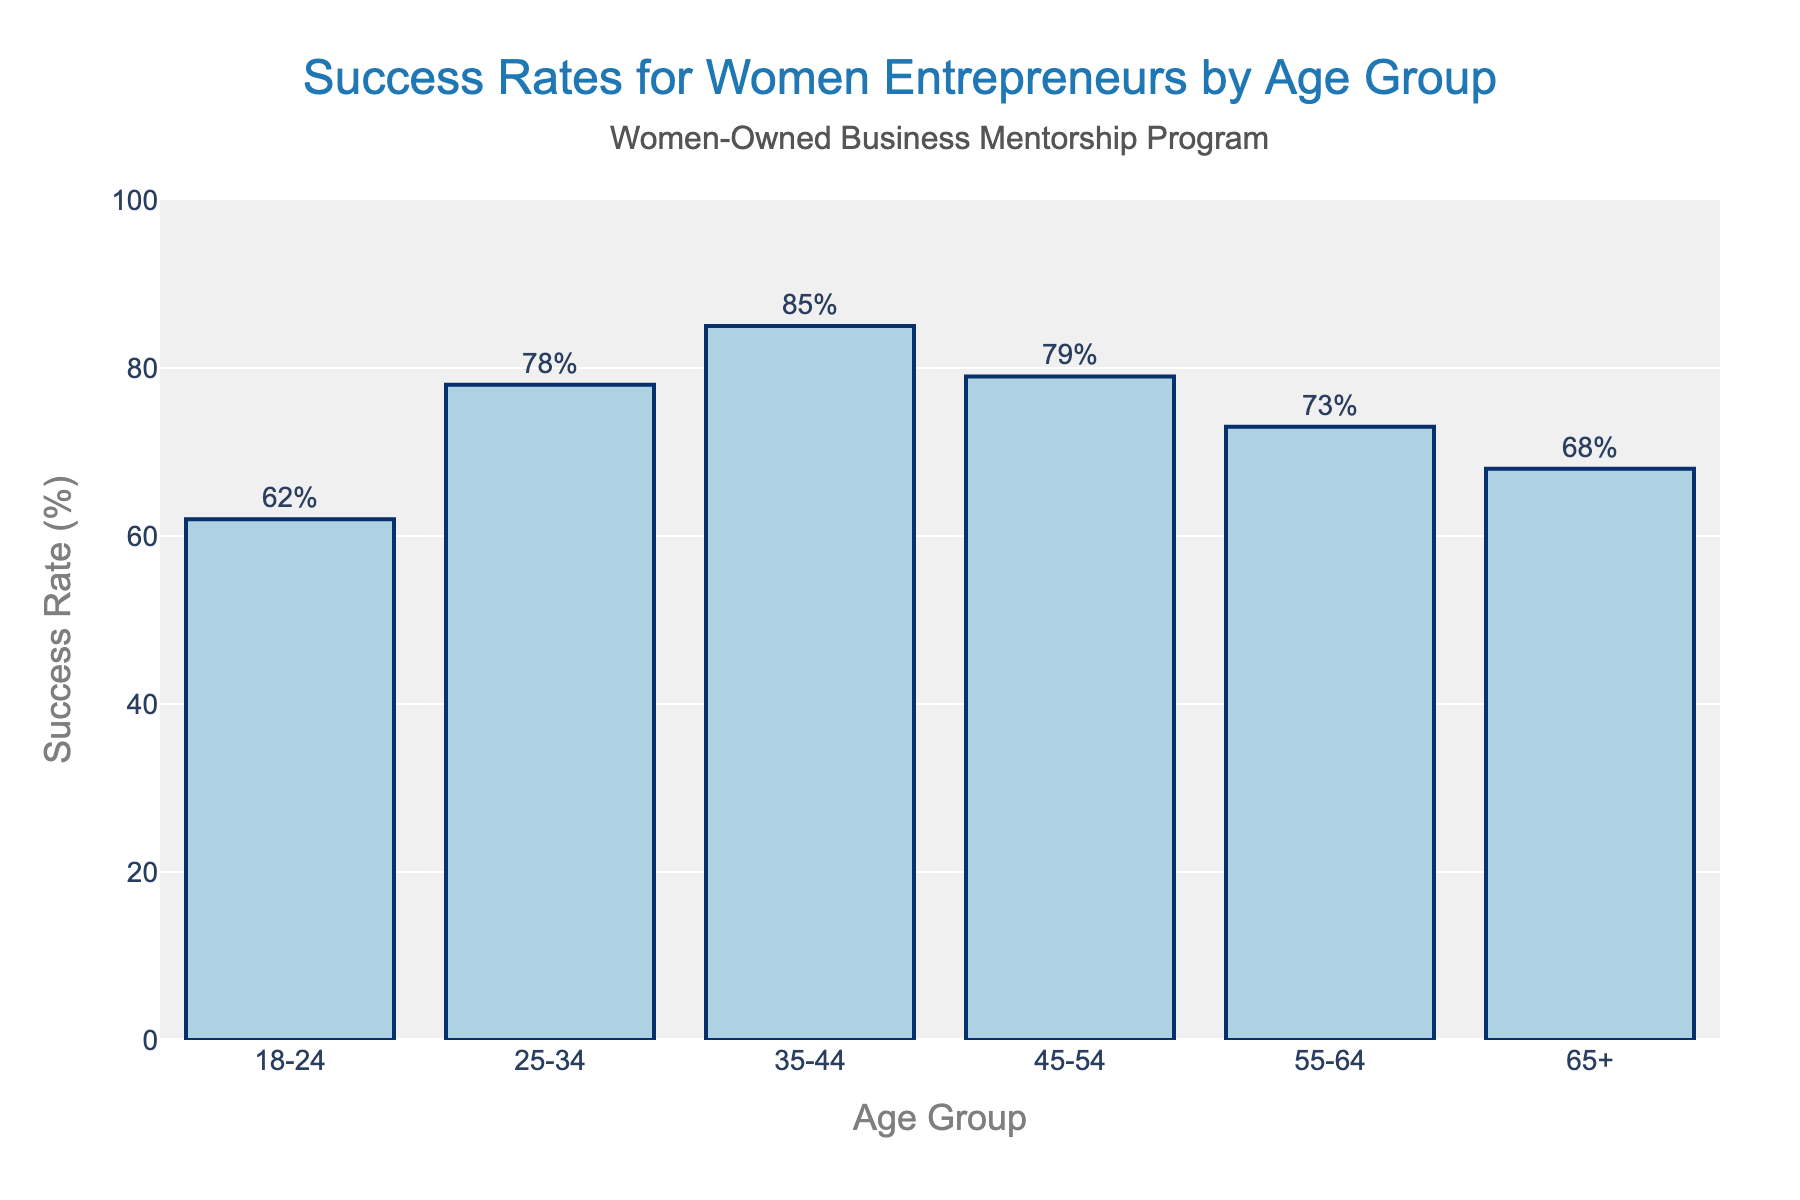What is the success rate for women entrepreneurs in the 35-44 age group? The bar corresponding to the 35-44 age group reaches up to 85% on the vertical axis.
Answer: 85% Which age group has the highest success rate? By inspecting the heights of the bars, the 35-44 age group has the highest bar, indicating the highest success rate.
Answer: 35-44 What's the average success rate for the age groups 18-24 and 65+? The success rates for the 18-24 and 65+ age groups are 62% and 68%, respectively. Adding these two percentages and dividing by 2 gives the average: (62 + 68) / 2 = 65%.
Answer: 65% How much higher is the success rate for the 25-34 age group compared to the 55-64 age group? The success rate for the 25-34 age group is 78%, and for the 55-64 age group, it is 73%. The difference is 78% - 73% = 5%.
Answer: 5% Which age groups have a success rate above 70%? Bars above the 70% mark correspond to the 25-34, 35-44, 45-54, and 55-64 age groups.
Answer: 25-34, 35-44, 45-54, 55-64 What is the total of all success rates for the given age groups? Add the success rates for all age groups: 62% + 78% + 85% + 79% + 73% + 68% = 445%.
Answer: 445% What is the difference in success rates between the youngest and the oldest age groups? The success rate for the 18-24 age group is 62%, and for the 65+ age group, it is 68%. The difference is 68% - 62% = 6%.
Answer: 6% Which age group has a success rate closest to 75%? By checking the bars, the success rates of 78% for the 25-34 age group and 73% for the 55-64 age group are closest to 75%.
Answer: 25-34, 55-64 What is the median success rate of the age groups? Ordering the success rates: 62%, 68%, 73%, 78%, 79%, 85%. With six data points, the median is the average of the 3rd and 4th values: (73% + 78%) / 2 = 75.5%.
Answer: 75.5% 